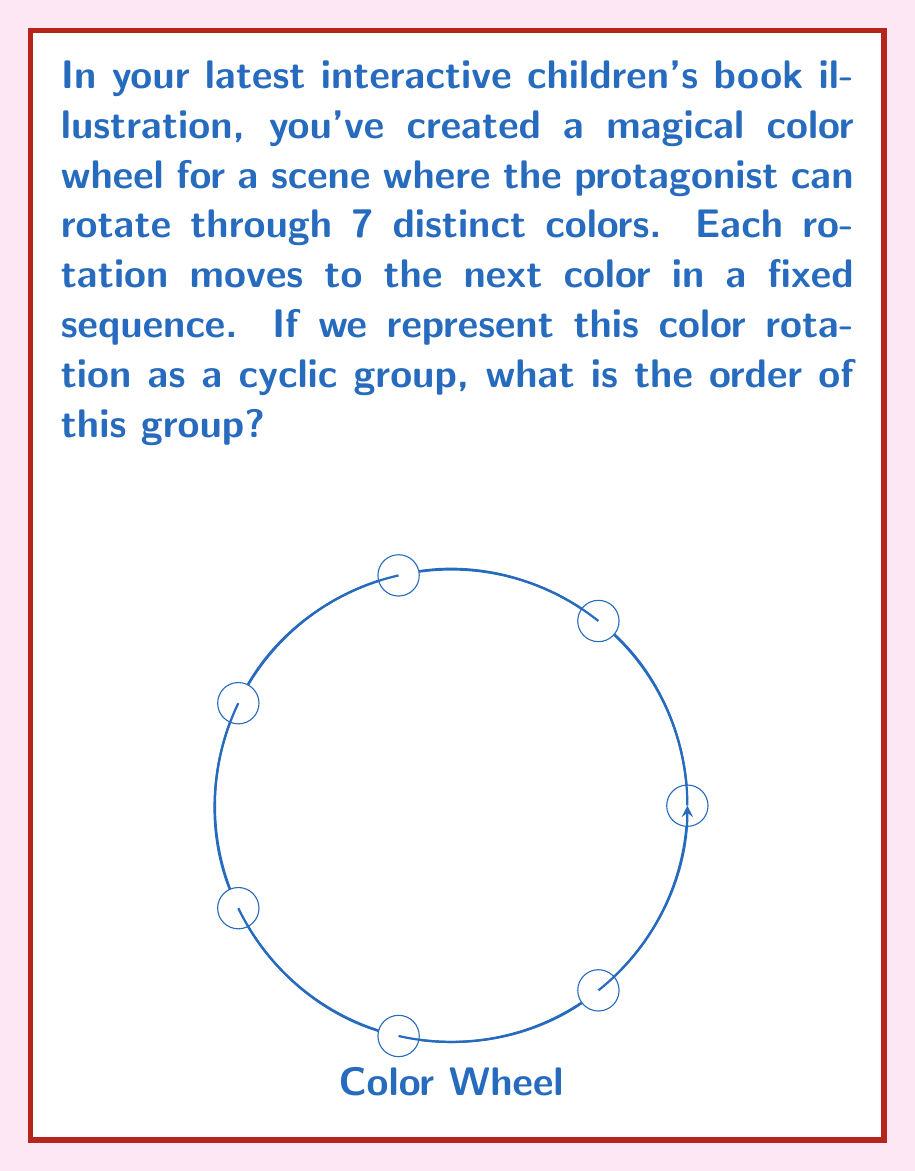Show me your answer to this math problem. To determine the order of the cyclic group representing color rotations, we need to follow these steps:

1) First, recall that in group theory, the order of a cyclic group is equal to the number of distinct elements in the group.

2) In this case, each distinct color represents an element of the group.

3) We are given that there are 7 distinct colors in the rotation sequence.

4) The group operation here is the rotation, which moves from one color to the next in a fixed sequence.

5) Starting from any color and applying the rotation operation repeatedly, we will cycle through all 7 colors before returning to the starting color.

6) This means that the smallest positive integer $n$ such that $g^n = e$ (where $g$ is the generator of the group and $e$ is the identity element) is 7.

7) Therefore, the order of this cyclic group is 7.

Mathematically, we can represent this cyclic group as:

$$C_7 = \langle g \mid g^7 = e \rangle$$

where $g$ represents a single color rotation.
Answer: 7 